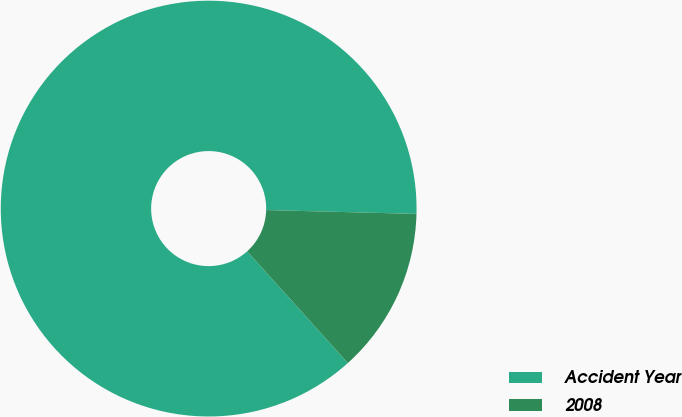<chart> <loc_0><loc_0><loc_500><loc_500><pie_chart><fcel>Accident Year<fcel>2008<nl><fcel>87.08%<fcel>12.92%<nl></chart> 